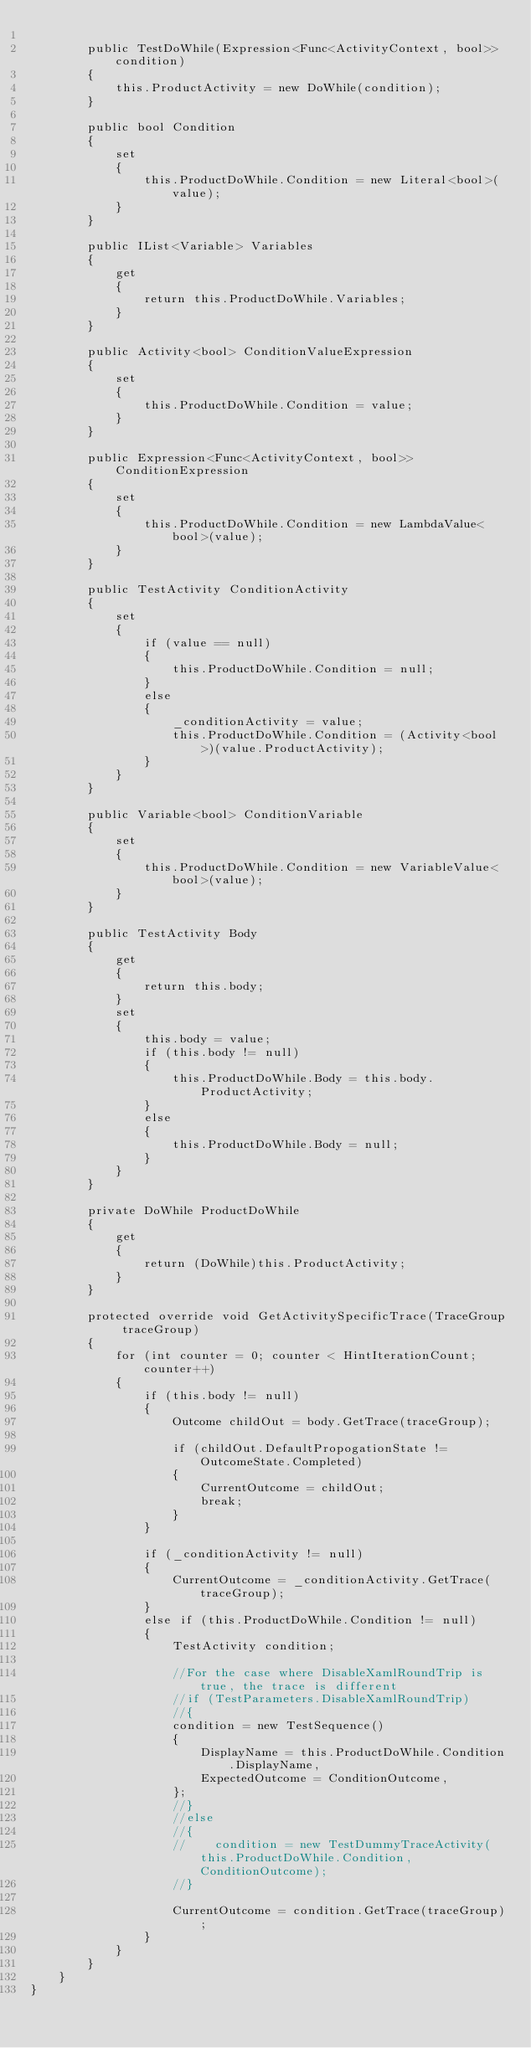Convert code to text. <code><loc_0><loc_0><loc_500><loc_500><_C#_>
        public TestDoWhile(Expression<Func<ActivityContext, bool>> condition)
        {
            this.ProductActivity = new DoWhile(condition);
        }

        public bool Condition
        {
            set
            {
                this.ProductDoWhile.Condition = new Literal<bool>(value);
            }
        }

        public IList<Variable> Variables
        {
            get
            {
                return this.ProductDoWhile.Variables;
            }
        }

        public Activity<bool> ConditionValueExpression
        {
            set
            {
                this.ProductDoWhile.Condition = value;
            }
        }

        public Expression<Func<ActivityContext, bool>> ConditionExpression
        {
            set
            {
                this.ProductDoWhile.Condition = new LambdaValue<bool>(value);
            }
        }

        public TestActivity ConditionActivity
        {
            set
            {
                if (value == null)
                {
                    this.ProductDoWhile.Condition = null;
                }
                else
                {
                    _conditionActivity = value;
                    this.ProductDoWhile.Condition = (Activity<bool>)(value.ProductActivity);
                }
            }
        }

        public Variable<bool> ConditionVariable
        {
            set
            {
                this.ProductDoWhile.Condition = new VariableValue<bool>(value);
            }
        }

        public TestActivity Body
        {
            get
            {
                return this.body;
            }
            set
            {
                this.body = value;
                if (this.body != null)
                {
                    this.ProductDoWhile.Body = this.body.ProductActivity;
                }
                else
                {
                    this.ProductDoWhile.Body = null;
                }
            }
        }

        private DoWhile ProductDoWhile
        {
            get
            {
                return (DoWhile)this.ProductActivity;
            }
        }

        protected override void GetActivitySpecificTrace(TraceGroup traceGroup)
        {
            for (int counter = 0; counter < HintIterationCount; counter++)
            {
                if (this.body != null)
                {
                    Outcome childOut = body.GetTrace(traceGroup);

                    if (childOut.DefaultPropogationState != OutcomeState.Completed)
                    {
                        CurrentOutcome = childOut;
                        break;
                    }
                }

                if (_conditionActivity != null)
                {
                    CurrentOutcome = _conditionActivity.GetTrace(traceGroup);
                }
                else if (this.ProductDoWhile.Condition != null)
                {
                    TestActivity condition;

                    //For the case where DisableXamlRoundTrip is true, the trace is different
                    //if (TestParameters.DisableXamlRoundTrip)
                    //{
                    condition = new TestSequence()
                    {
                        DisplayName = this.ProductDoWhile.Condition.DisplayName,
                        ExpectedOutcome = ConditionOutcome,
                    };
                    //}
                    //else
                    //{
                    //    condition = new TestDummyTraceActivity(this.ProductDoWhile.Condition, ConditionOutcome);
                    //}

                    CurrentOutcome = condition.GetTrace(traceGroup);
                }
            }
        }
    }
}
</code> 